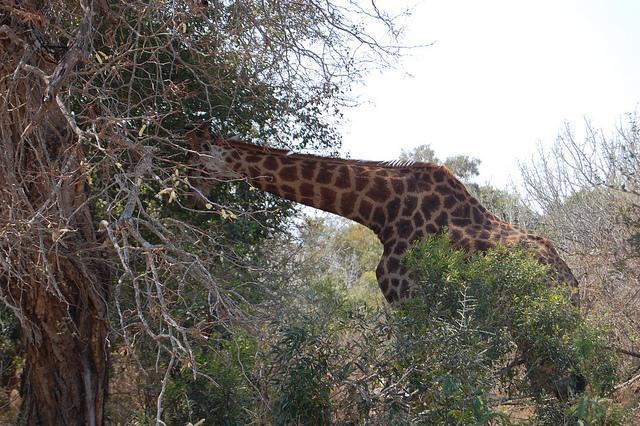How many giraffes are there?
Give a very brief answer. 1. 